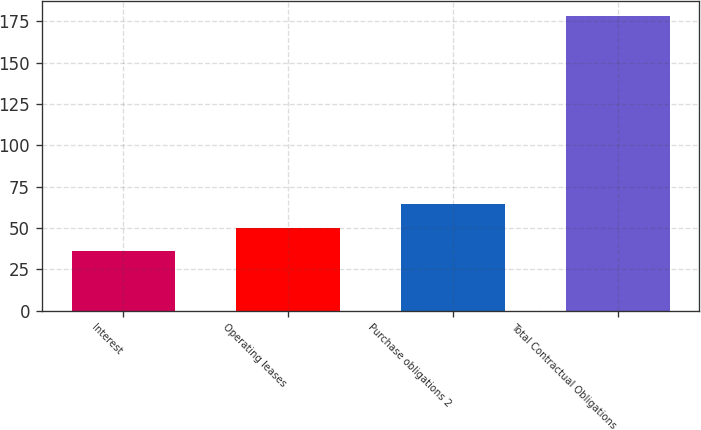<chart> <loc_0><loc_0><loc_500><loc_500><bar_chart><fcel>Interest<fcel>Operating leases<fcel>Purchase obligations 2<fcel>Total Contractual Obligations<nl><fcel>36<fcel>50.23<fcel>64.46<fcel>178.3<nl></chart> 